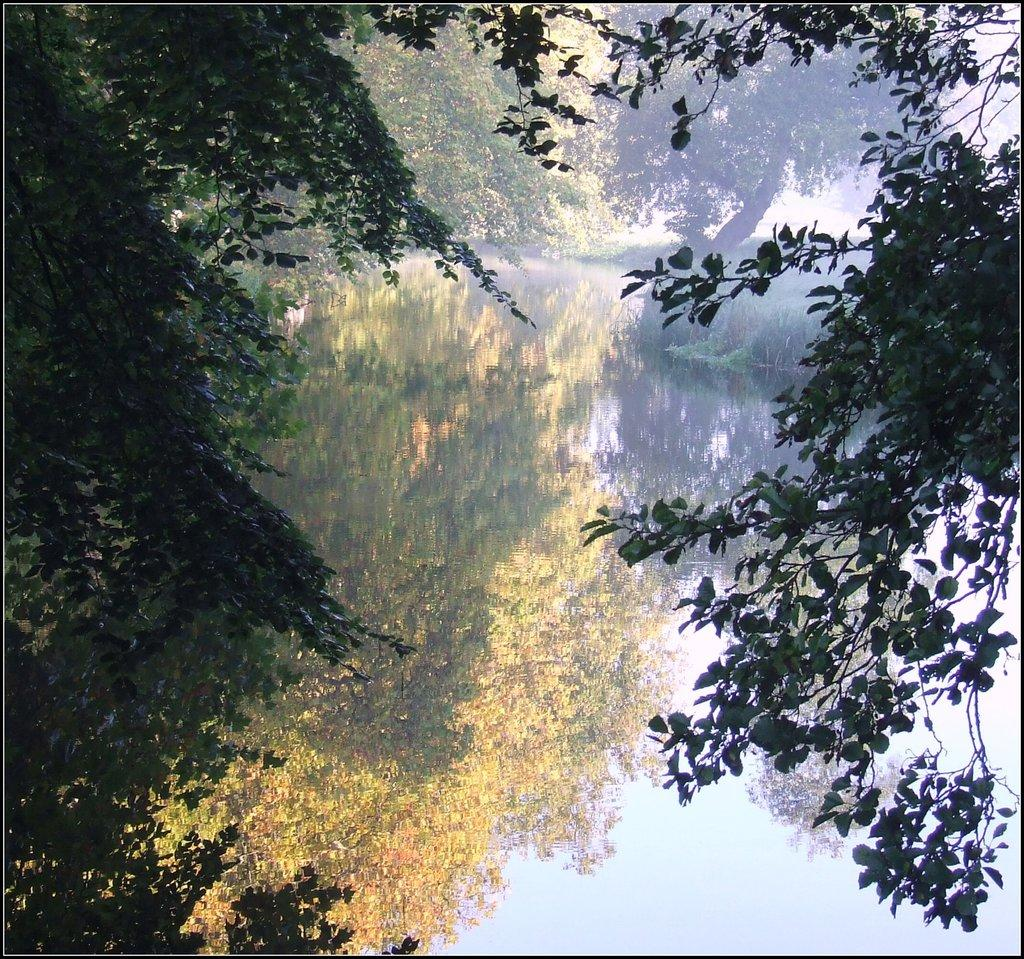What type of vegetation is present on the left side of the image? There are trees on the left side of the image. What type of vegetation is present on the right side of the image? There are trees on the right side of the image. What can be seen in the middle of the image? There is water and grass in the middle of the image. What can be observed on the water's surface? The reflections of trees and the sky are visible on the water. What type of stocking is hanging from the tree on the left side of the image? There is no stocking present in the image; it only features trees, water, grass, and reflections. Where is the fire hydrant located in the image? There is no fire hydrant present in the image. 